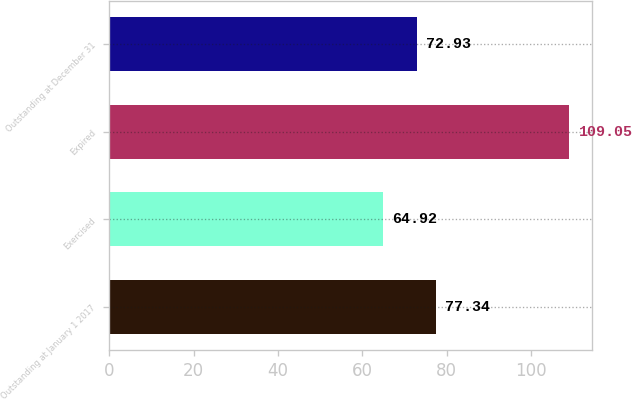Convert chart. <chart><loc_0><loc_0><loc_500><loc_500><bar_chart><fcel>Outstanding at January 1 2017<fcel>Exercised<fcel>Expired<fcel>Outstanding at December 31<nl><fcel>77.34<fcel>64.92<fcel>109.05<fcel>72.93<nl></chart> 